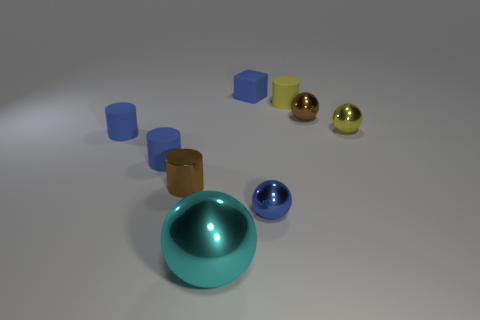Subtract 1 balls. How many balls are left? 3 Subtract all purple cubes. How many blue cylinders are left? 2 Subtract all rubber cylinders. How many cylinders are left? 1 Subtract all yellow cylinders. How many cylinders are left? 3 Subtract all cylinders. How many objects are left? 5 Subtract all red balls. Subtract all blue cylinders. How many balls are left? 4 Add 3 small shiny objects. How many small shiny objects are left? 7 Add 4 yellow rubber cylinders. How many yellow rubber cylinders exist? 5 Subtract 1 yellow cylinders. How many objects are left? 8 Subtract all shiny cylinders. Subtract all small blue cubes. How many objects are left? 7 